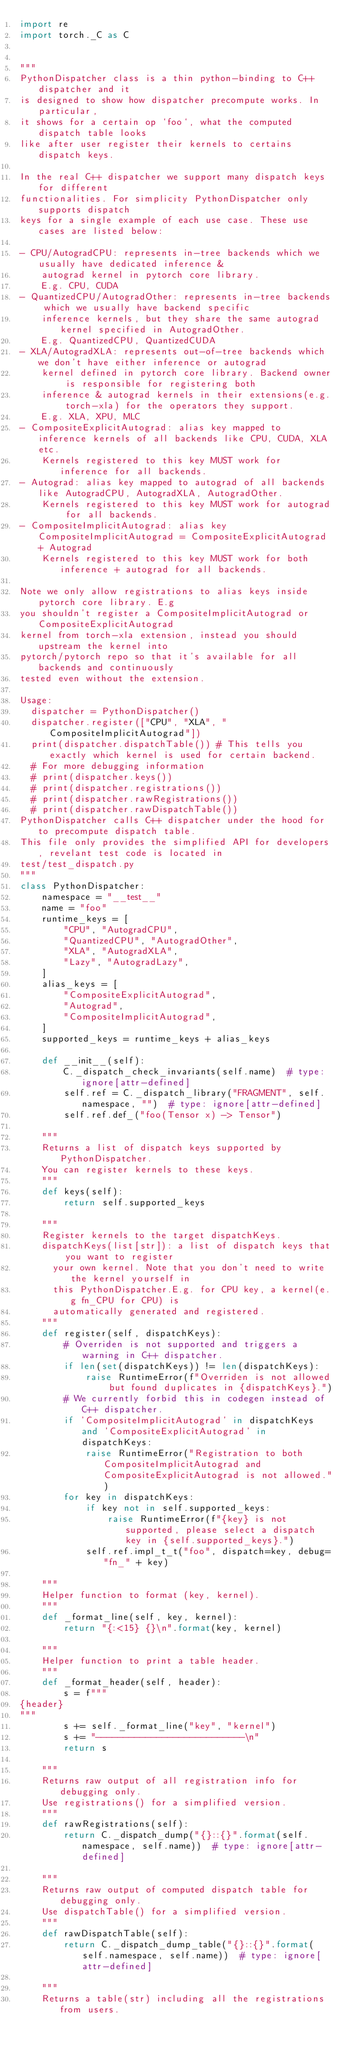Convert code to text. <code><loc_0><loc_0><loc_500><loc_500><_Python_>import re
import torch._C as C


"""
PythonDispatcher class is a thin python-binding to C++ dispatcher and it
is designed to show how dispatcher precompute works. In particular,
it shows for a certain op `foo`, what the computed dispatch table looks
like after user register their kernels to certains dispatch keys.

In the real C++ dispatcher we support many dispatch keys for different
functionalities. For simplicity PythonDispatcher only supports dispatch
keys for a single example of each use case. These use cases are listed below:

- CPU/AutogradCPU: represents in-tree backends which we usually have dedicated inference &
    autograd kernel in pytorch core library.
    E.g. CPU, CUDA
- QuantizedCPU/AutogradOther: represents in-tree backends which we usually have backend specific
    inference kernels, but they share the same autograd kernel specified in AutogradOther.
    E.g. QuantizedCPU, QuantizedCUDA
- XLA/AutogradXLA: represents out-of-tree backends which we don't have either inference or autograd
    kernel defined in pytorch core library. Backend owner is responsible for registering both
    inference & autograd kernels in their extensions(e.g. torch-xla) for the operators they support.
    E.g. XLA, XPU, MLC
- CompositeExplicitAutograd: alias key mapped to inference kernels of all backends like CPU, CUDA, XLA etc.
    Kernels registered to this key MUST work for inference for all backends.
- Autograd: alias key mapped to autograd of all backends like AutogradCPU, AutogradXLA, AutogradOther.
    Kernels registered to this key MUST work for autograd for all backends.
- CompositeImplicitAutograd: alias key CompositeImplicitAutograd = CompositeExplicitAutograd + Autograd
    Kernels registered to this key MUST work for both inference + autograd for all backends.

Note we only allow registrations to alias keys inside pytorch core library. E.g
you shouldn't register a CompositeImplicitAutograd or CompositeExplicitAutograd
kernel from torch-xla extension, instead you should upstream the kernel into
pytorch/pytorch repo so that it's available for all backends and continuously
tested even without the extension.

Usage:
  dispatcher = PythonDispatcher()
  dispatcher.register(["CPU", "XLA", "CompositeImplicitAutograd"])
  print(dispatcher.dispatchTable()) # This tells you exactly which kernel is used for certain backend.
  # For more debugging information
  # print(dispatcher.keys())
  # print(dispatcher.registrations())
  # print(dispatcher.rawRegistrations())
  # print(dispatcher.rawDispatchTable())
PythonDispatcher calls C++ dispatcher under the hood for to precompute dispatch table.
This file only provides the simplified API for developers, revelant test code is located in
test/test_dispatch.py
"""
class PythonDispatcher:
    namespace = "__test__"
    name = "foo"
    runtime_keys = [
        "CPU", "AutogradCPU",
        "QuantizedCPU", "AutogradOther",
        "XLA", "AutogradXLA",
        "Lazy", "AutogradLazy",
    ]
    alias_keys = [
        "CompositeExplicitAutograd",
        "Autograd",
        "CompositeImplicitAutograd",
    ]
    supported_keys = runtime_keys + alias_keys

    def __init__(self):
        C._dispatch_check_invariants(self.name)  # type: ignore[attr-defined]
        self.ref = C._dispatch_library("FRAGMENT", self.namespace, "")  # type: ignore[attr-defined]
        self.ref.def_("foo(Tensor x) -> Tensor")

    """
    Returns a list of dispatch keys supported by PythonDispatcher.
    You can register kernels to these keys.
    """
    def keys(self):
        return self.supported_keys

    """
    Register kernels to the target dispatchKeys.
    dispatchKeys(list[str]): a list of dispatch keys that you want to register
      your own kernel. Note that you don't need to write the kernel yourself in
      this PythonDispatcher.E.g. for CPU key, a kernel(e.g fn_CPU for CPU) is
      automatically generated and registered.
    """
    def register(self, dispatchKeys):
        # Overriden is not supported and triggers a warning in C++ dispatcher.
        if len(set(dispatchKeys)) != len(dispatchKeys):
            raise RuntimeError(f"Overriden is not allowed but found duplicates in {dispatchKeys}.")
        # We currently forbid this in codegen instead of C++ dispatcher.
        if 'CompositeImplicitAutograd' in dispatchKeys and 'CompositeExplicitAutograd' in dispatchKeys:
            raise RuntimeError("Registration to both CompositeImplicitAutograd and CompositeExplicitAutograd is not allowed.")
        for key in dispatchKeys:
            if key not in self.supported_keys:
                raise RuntimeError(f"{key} is not supported, please select a dispatch key in {self.supported_keys}.")
            self.ref.impl_t_t("foo", dispatch=key, debug="fn_" + key)

    """
    Helper function to format (key, kernel).
    """
    def _format_line(self, key, kernel):
        return "{:<15} {}\n".format(key, kernel)

    """
    Helper function to print a table header.
    """
    def _format_header(self, header):
        s = f"""
{header}
"""
        s += self._format_line("key", "kernel")
        s += "---------------------------\n"
        return s

    """
    Returns raw output of all registration info for debugging only.
    Use registrations() for a simplified version.
    """
    def rawRegistrations(self):
        return C._dispatch_dump("{}::{}".format(self.namespace, self.name))  # type: ignore[attr-defined]

    """
    Returns raw output of computed dispatch table for debugging only.
    Use dispatchTable() for a simplified version.
    """
    def rawDispatchTable(self):
        return C._dispatch_dump_table("{}::{}".format(self.namespace, self.name))  # type: ignore[attr-defined]

    """
    Returns a table(str) including all the registrations from users.</code> 